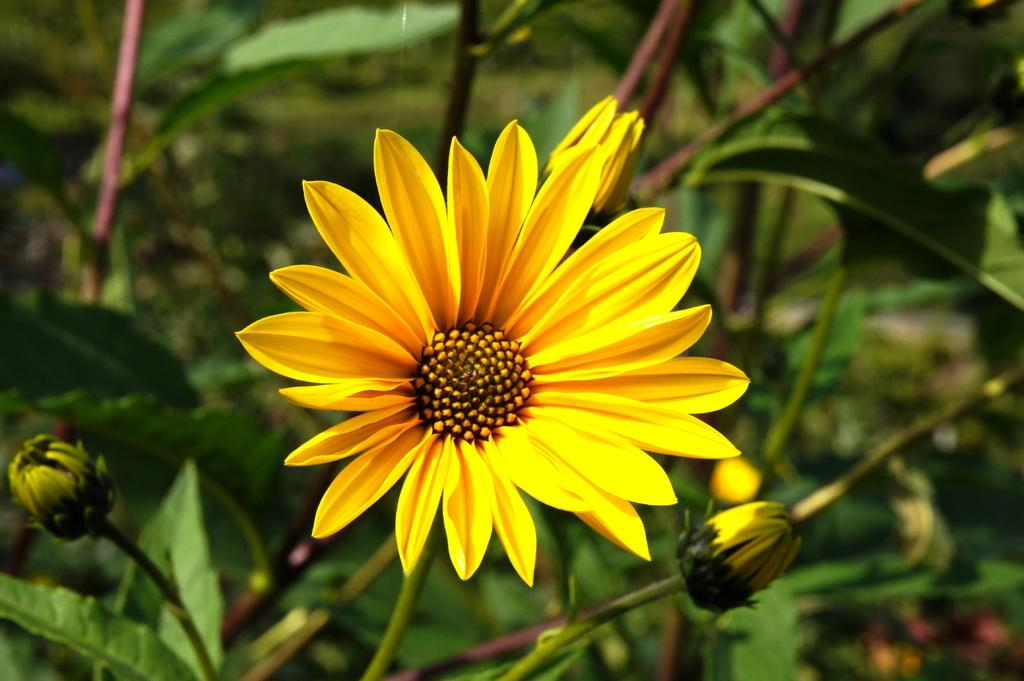What type of plant elements can be seen in the image? There are flower buds and a flower in the image. How is the background of the image depicted? The background of the image is blurred. What else can be seen in the background of the image? There are plants in the background of the image. What type of instrument is being played by the owl in the image? There is no owl or instrument present in the image. Can you describe the girl's outfit in the image? There is no girl present in the image. 